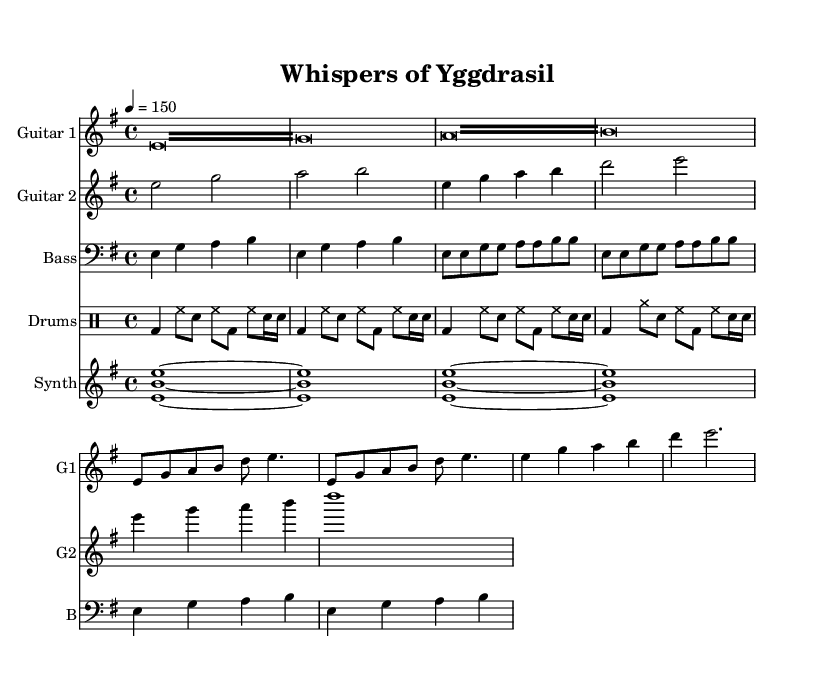What is the key signature of this music? The key signature is indicated after the word "key" and shows E minor, which has one sharp (F#).
Answer: E minor What is the time signature of this music? The time signature is presented after the word "time," and it shows 4/4, which means there are four beats in each measure.
Answer: 4/4 What is the tempo marking for this piece? The tempo is marked with a number (4 = 150), indicating that a quarter note should be played at 150 beats per minute.
Answer: 150 How many measures are in the intro section? The intro section consists of two repeated tremolo patterns, each lasting for one measure, giving a total of two measures in the intro.
Answer: 2 What is the predominant instrument in the synth part? The synth part is clearly labeled, and it shows that it plays sustained chords which make it a prominent texture against the guitars and drums.
Answer: Synth What section comes after the verse in this song structure? The music structure indicates a typical format where the chorus directly follows the verse, as seen in both guitar parts.
Answer: Chorus Which instrument plays a variation with cymbals? Upon examining the drum part, it shows a specific variation where cymbals (cymr) are noted, which indicates that the drum player is using cymbals in this part.
Answer: Drums 